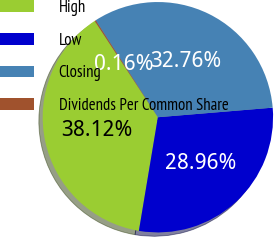<chart> <loc_0><loc_0><loc_500><loc_500><pie_chart><fcel>High<fcel>Low<fcel>Closing<fcel>Dividends Per Common Share<nl><fcel>38.12%<fcel>28.96%<fcel>32.76%<fcel>0.16%<nl></chart> 